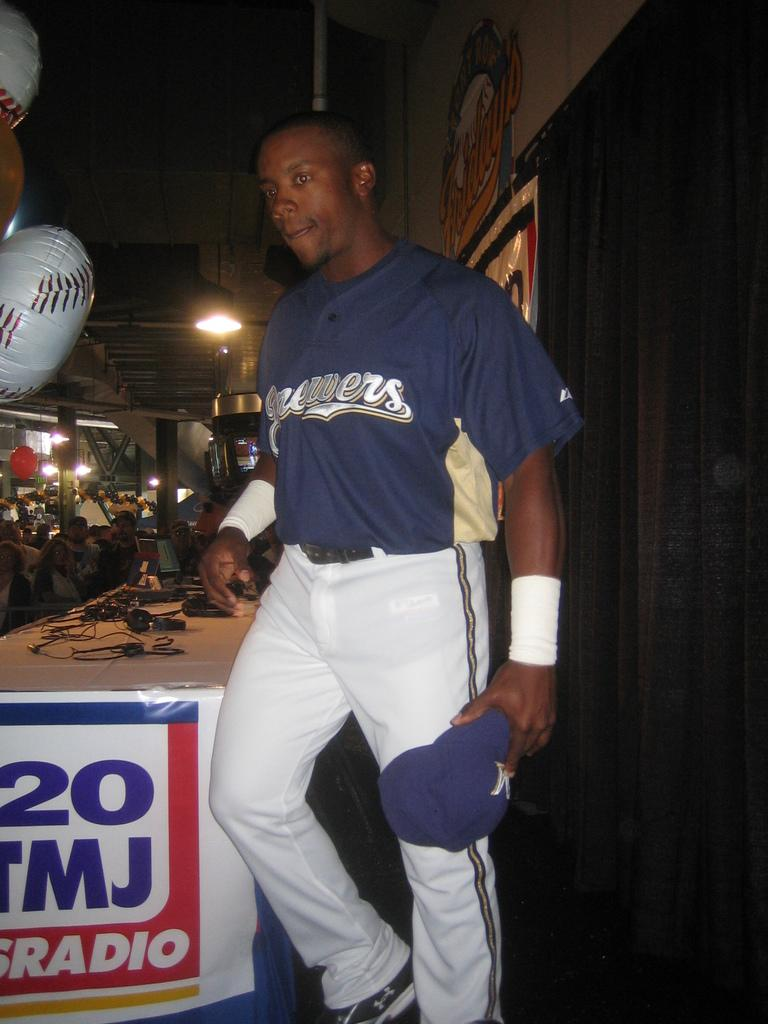<image>
Give a short and clear explanation of the subsequent image. A man in white pants and a blue shirt stands in front of a sign reading Radio. 